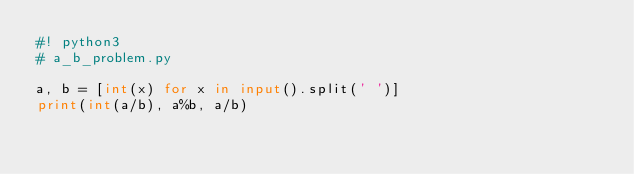Convert code to text. <code><loc_0><loc_0><loc_500><loc_500><_Python_>#! python3
# a_b_problem.py

a, b = [int(x) for x in input().split(' ')]
print(int(a/b), a%b, a/b)

</code> 